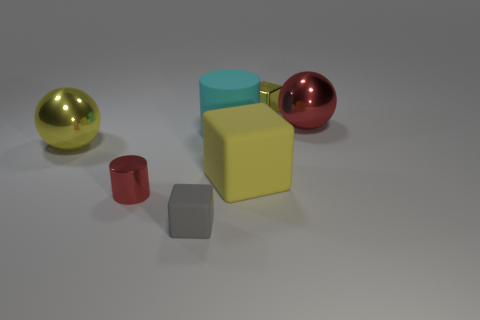Subtract all large cubes. How many cubes are left? 2 Add 2 gray objects. How many objects exist? 9 Subtract all cylinders. How many objects are left? 5 Subtract all large yellow blocks. Subtract all large red rubber cylinders. How many objects are left? 6 Add 3 red metal things. How many red metal things are left? 5 Add 5 tiny cylinders. How many tiny cylinders exist? 6 Subtract 0 cyan cubes. How many objects are left? 7 